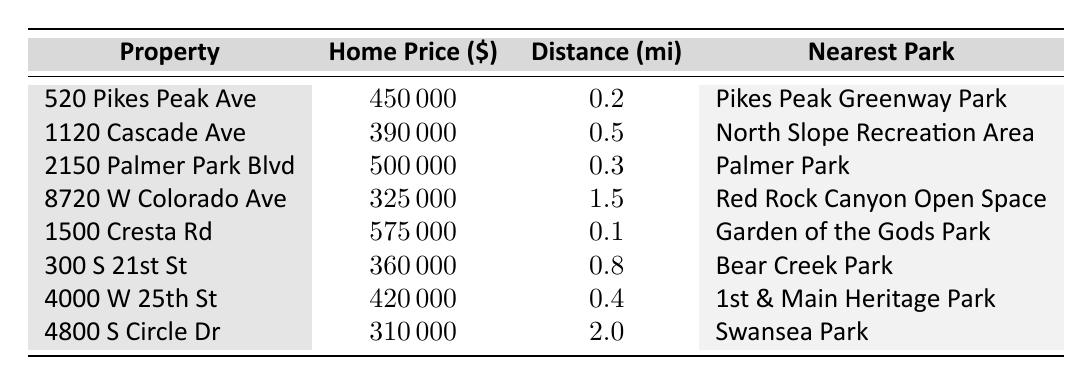what is the home price of the property at 1500 Cresta Rd? The table lists "1500 Cresta Rd" under the column "Property," and its corresponding home price in the "Home Price" column is $575,000.
Answer: $575,000 which property is closest to a park? The "Distance (mi)" column indicates the closest distance to a park, which is 0.1 miles for the property "1500 Cresta Rd."
Answer: 1500 Cresta Rd what is the average home price of the properties listed? To calculate the average, sum up all the home prices: 450000 + 390000 + 500000 + 325000 + 575000 + 360000 + 420000 + 310000 = 2830000. Then divide by 8, which gives: 2830000 / 8 = 353750.
Answer: $353,750 is there any property priced above $500,000? By reviewing the "Home Price" column, the properties "2150 Palmer Park Blvd" and "1500 Cresta Rd" have prices of $500,000 and $575,000, respectively, confirming there are properties above $500,000.
Answer: Yes which two properties have the furthest distance from a park? The table shows "4800 S Circle Dr" at 2.0 miles and "8720 W Colorado Ave" at 1.5 miles as the two properties with the furthest distances to local parks.
Answer: 4800 S Circle Dr and 8720 W Colorado Ave what is the difference in home price between the most expensive and the least expensive property? The most expensive property is "1500 Cresta Rd" at $575,000 and the least expensive is "4800 S Circle Dr" at $310,000. Thus, the difference is $575,000 - $310,000 = $265,000.
Answer: $265,000 does every property have a distance to a park under 2 miles? By checking the "Distance (mi)" column, indeed all properties have distances less than or equal to 2 miles, with the maximum at 2.0 miles for "4800 S Circle Dr."
Answer: Yes if you summarize the average distance to parks for the properties listed, what would it be? To calculate the average distance, sum the distances: 0.2 + 0.5 + 0.3 + 1.5 + 0.1 + 0.8 + 0.4 + 2.0 = 5.8 miles. Dividing by the 8 properties gives: 5.8 / 8 = 0.725 miles.
Answer: 0.725 miles 